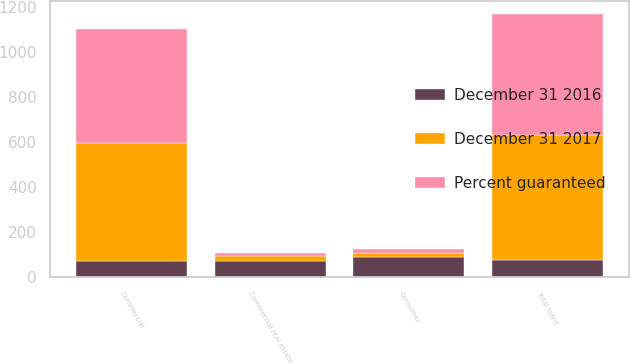Convert chart. <chart><loc_0><loc_0><loc_500><loc_500><stacked_bar_chart><ecel><fcel>Commercial<fcel>Commercial real estate<fcel>Consumer<fcel>Total loans<nl><fcel>Percent guaranteed<fcel>507<fcel>14<fcel>16<fcel>537<nl><fcel>December 31 2016<fcel>75<fcel>75<fcel>92<fcel>76<nl><fcel>December 31 2017<fcel>519<fcel>18<fcel>17<fcel>554<nl></chart> 